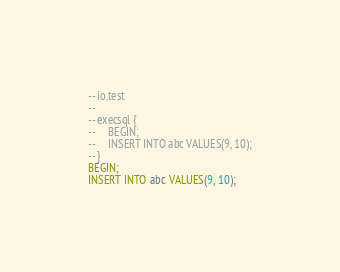Convert code to text. <code><loc_0><loc_0><loc_500><loc_500><_SQL_>-- io.test
-- 
-- execsql {
--     BEGIN;
--     INSERT INTO abc VALUES(9, 10);
-- }
BEGIN;
INSERT INTO abc VALUES(9, 10);</code> 